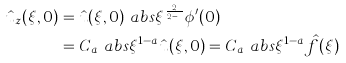<formula> <loc_0><loc_0><loc_500><loc_500>\hat { u } _ { z } ( \xi , 0 ) & = \hat { u } ( \xi , 0 ) \ a b s { \xi } ^ { \frac { 2 } { 2 - \alpha } } \phi ^ { \prime } ( 0 ) \\ & = C _ { a } \ a b s { \xi } ^ { 1 - a } \hat { u } ( \xi , 0 ) = C _ { a } \ a b s { \xi } ^ { 1 - a } \hat { f } ( \xi )</formula> 